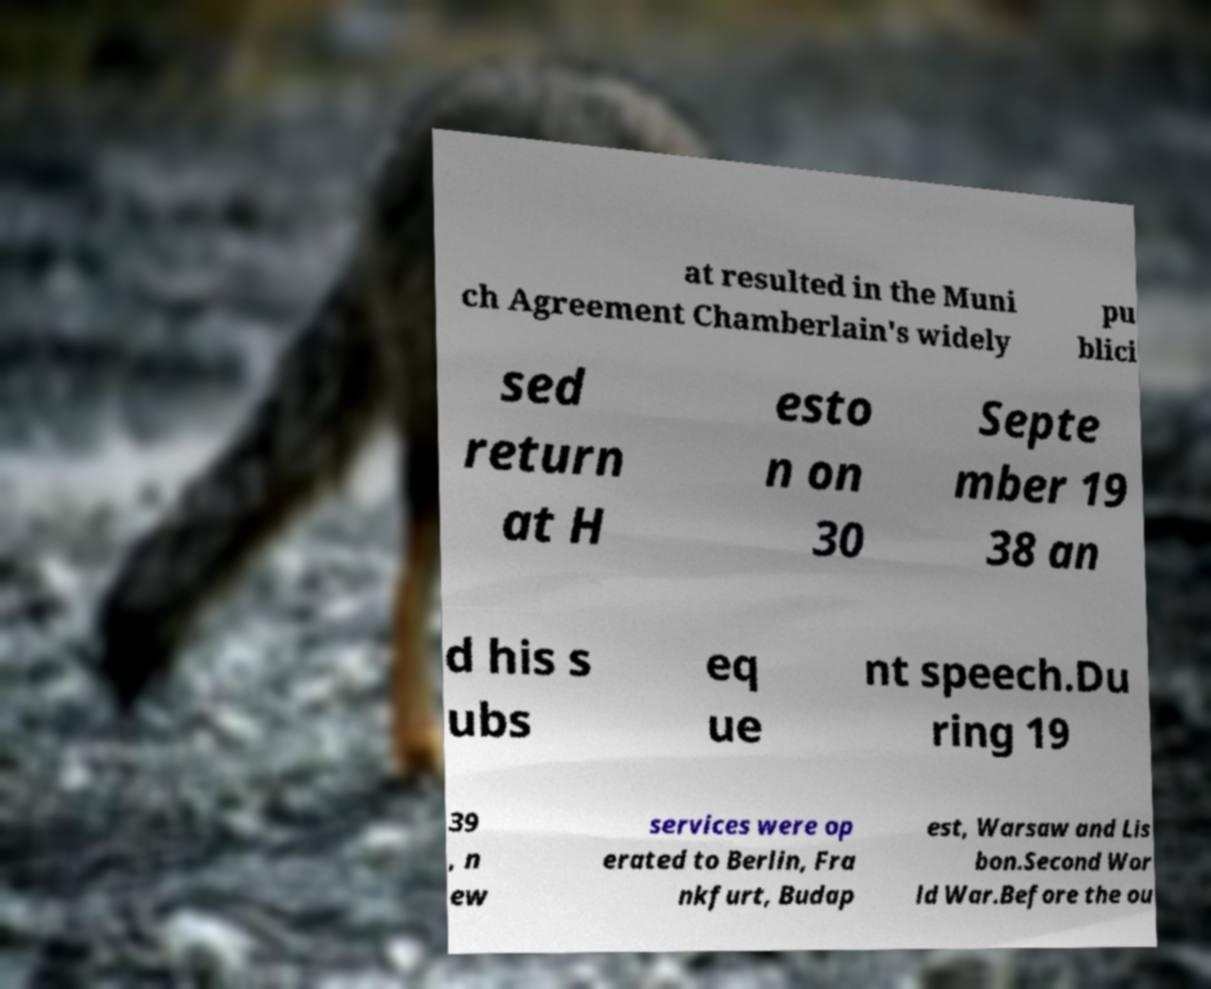Please identify and transcribe the text found in this image. at resulted in the Muni ch Agreement Chamberlain's widely pu blici sed return at H esto n on 30 Septe mber 19 38 an d his s ubs eq ue nt speech.Du ring 19 39 , n ew services were op erated to Berlin, Fra nkfurt, Budap est, Warsaw and Lis bon.Second Wor ld War.Before the ou 